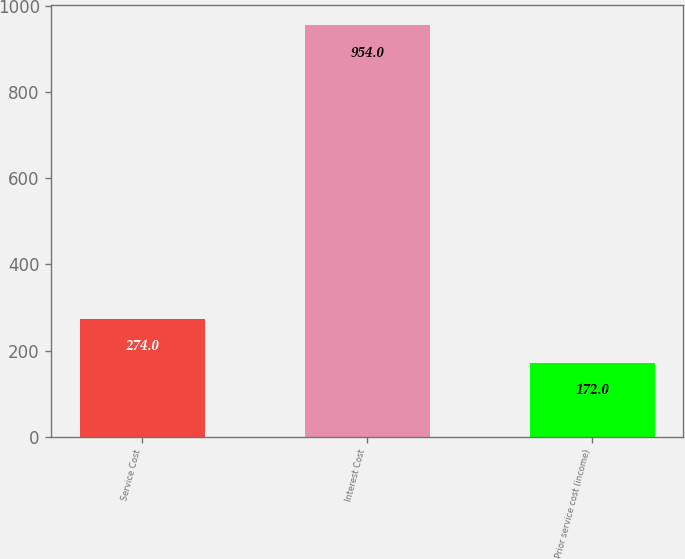<chart> <loc_0><loc_0><loc_500><loc_500><bar_chart><fcel>Service Cost<fcel>Interest Cost<fcel>Prior service cost (income)<nl><fcel>274<fcel>954<fcel>172<nl></chart> 